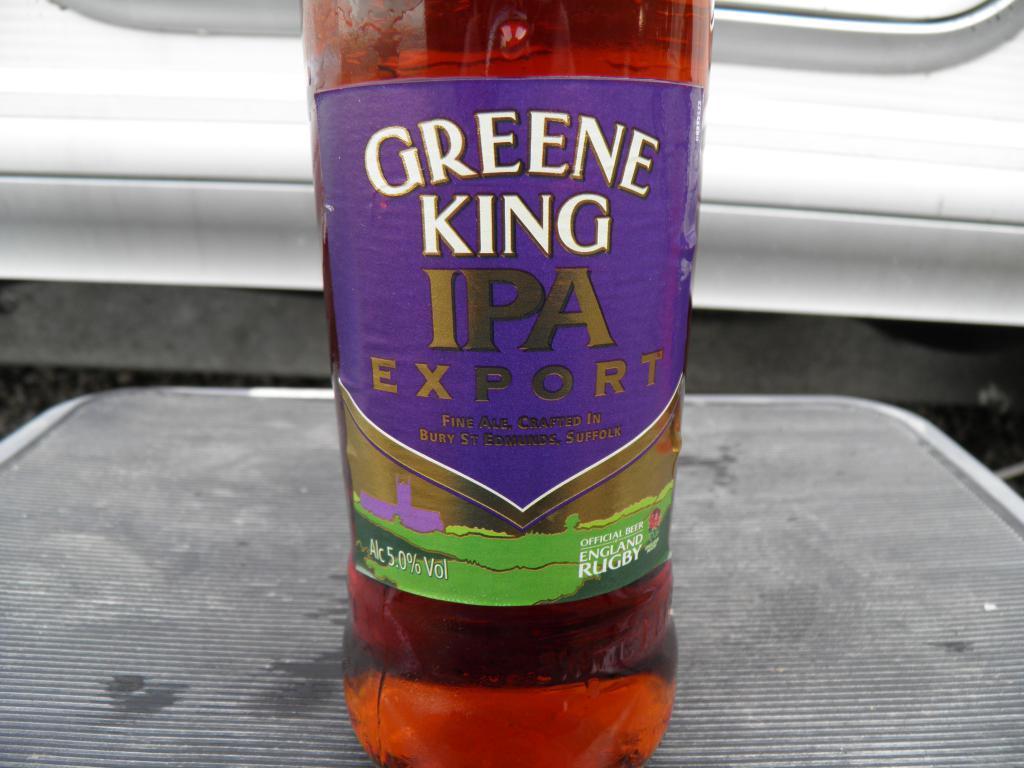How would you summarize this image in a sentence or two? In the picture there is a bottle on the bottle there is a liquid there is a sticker on the bottle the bottle is on the table. 